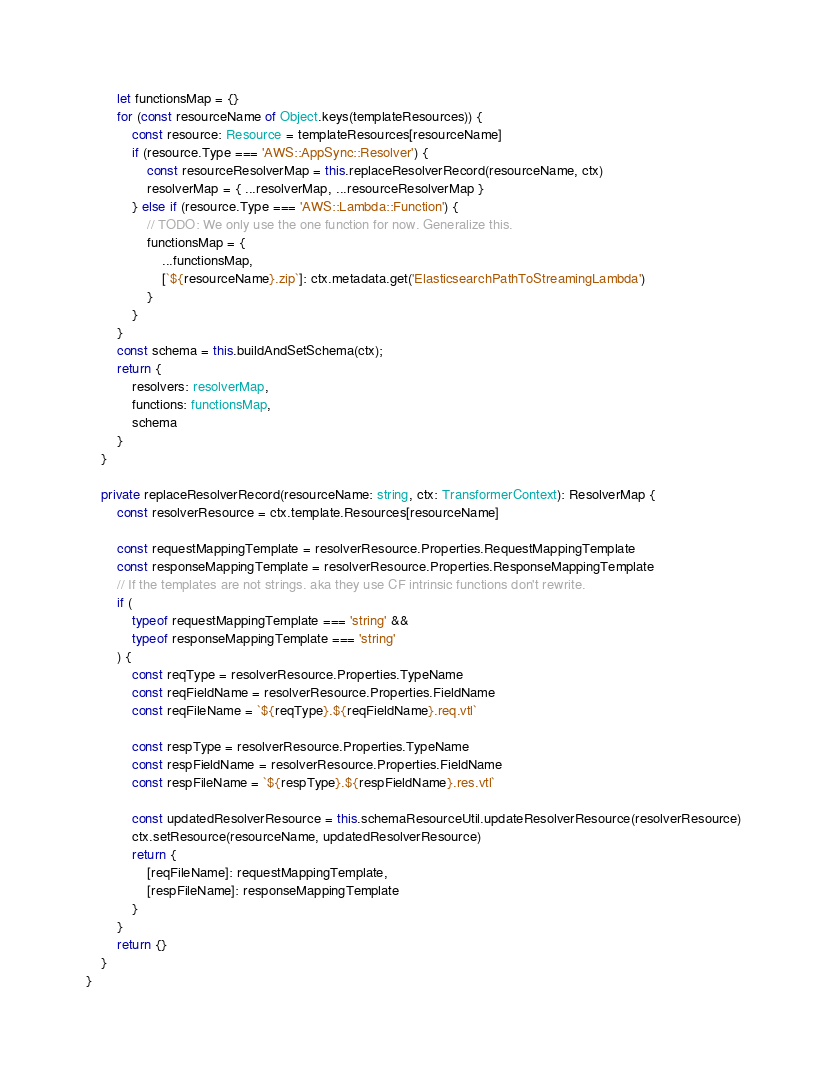Convert code to text. <code><loc_0><loc_0><loc_500><loc_500><_TypeScript_>        let functionsMap = {}
        for (const resourceName of Object.keys(templateResources)) {
            const resource: Resource = templateResources[resourceName]
            if (resource.Type === 'AWS::AppSync::Resolver') {
                const resourceResolverMap = this.replaceResolverRecord(resourceName, ctx)
                resolverMap = { ...resolverMap, ...resourceResolverMap }
            } else if (resource.Type === 'AWS::Lambda::Function') {
                // TODO: We only use the one function for now. Generalize this.
                functionsMap = {
                    ...functionsMap,
                    [`${resourceName}.zip`]: ctx.metadata.get('ElasticsearchPathToStreamingLambda')
                }
            }
        }
        const schema = this.buildAndSetSchema(ctx);
        return {
            resolvers: resolverMap,
            functions: functionsMap,
            schema
        }
    }

    private replaceResolverRecord(resourceName: string, ctx: TransformerContext): ResolverMap {
        const resolverResource = ctx.template.Resources[resourceName]

        const requestMappingTemplate = resolverResource.Properties.RequestMappingTemplate
        const responseMappingTemplate = resolverResource.Properties.ResponseMappingTemplate
        // If the templates are not strings. aka they use CF intrinsic functions don't rewrite.
        if (
            typeof requestMappingTemplate === 'string' &&
            typeof responseMappingTemplate === 'string'
        ) {
            const reqType = resolverResource.Properties.TypeName
            const reqFieldName = resolverResource.Properties.FieldName
            const reqFileName = `${reqType}.${reqFieldName}.req.vtl`

            const respType = resolverResource.Properties.TypeName
            const respFieldName = resolverResource.Properties.FieldName
            const respFileName = `${respType}.${respFieldName}.res.vtl`

            const updatedResolverResource = this.schemaResourceUtil.updateResolverResource(resolverResource)
            ctx.setResource(resourceName, updatedResolverResource)
            return {
                [reqFileName]: requestMappingTemplate,
                [respFileName]: responseMappingTemplate
            }
        }
        return {}
    }
}
</code> 